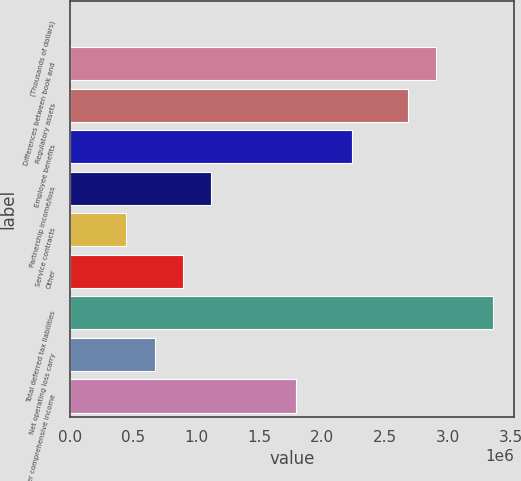<chart> <loc_0><loc_0><loc_500><loc_500><bar_chart><fcel>(Thousands of dollars)<fcel>Differences between book and<fcel>Regulatory assets<fcel>Employee benefits<fcel>Partnership income/loss<fcel>Service contracts<fcel>Other<fcel>Total deferred tax liabilities<fcel>Net operating loss carry<fcel>Other comprehensive income<nl><fcel>2003<fcel>2.90603e+06<fcel>2.68264e+06<fcel>2.23587e+06<fcel>1.11894e+06<fcel>448776<fcel>895550<fcel>3.3528e+06<fcel>672163<fcel>1.7891e+06<nl></chart> 